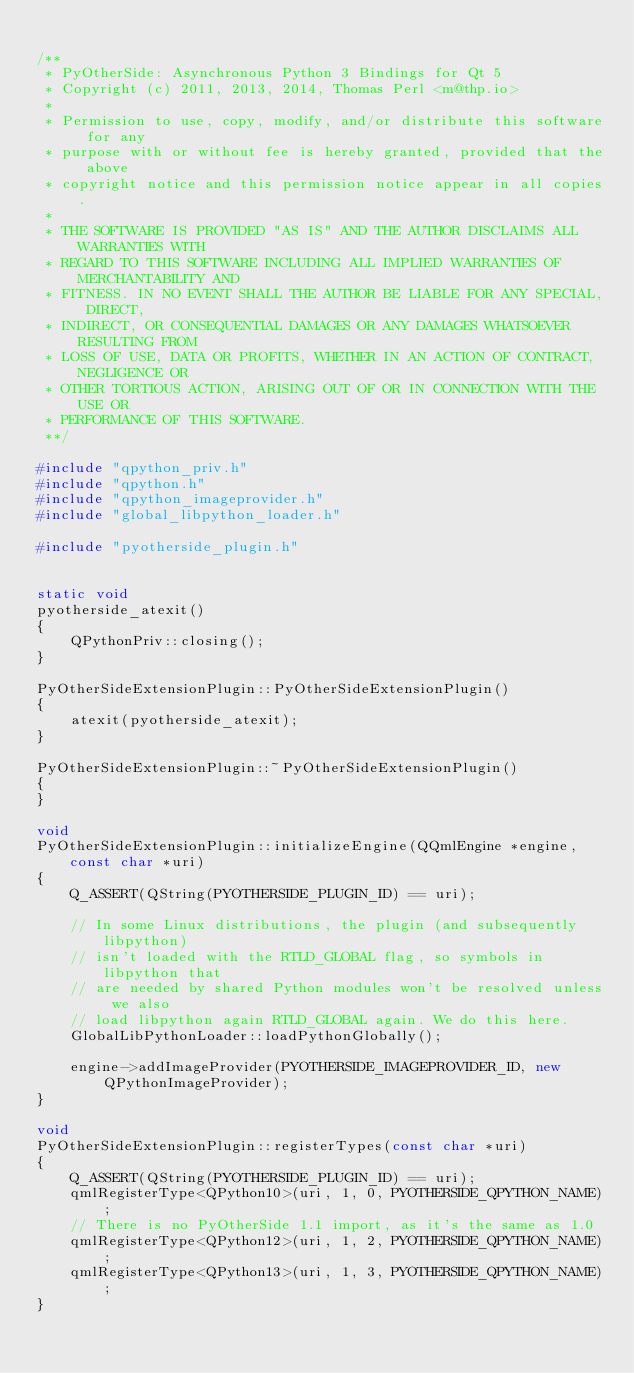Convert code to text. <code><loc_0><loc_0><loc_500><loc_500><_C++_>
/**
 * PyOtherSide: Asynchronous Python 3 Bindings for Qt 5
 * Copyright (c) 2011, 2013, 2014, Thomas Perl <m@thp.io>
 *
 * Permission to use, copy, modify, and/or distribute this software for any
 * purpose with or without fee is hereby granted, provided that the above
 * copyright notice and this permission notice appear in all copies.
 *
 * THE SOFTWARE IS PROVIDED "AS IS" AND THE AUTHOR DISCLAIMS ALL WARRANTIES WITH
 * REGARD TO THIS SOFTWARE INCLUDING ALL IMPLIED WARRANTIES OF MERCHANTABILITY AND
 * FITNESS. IN NO EVENT SHALL THE AUTHOR BE LIABLE FOR ANY SPECIAL, DIRECT,
 * INDIRECT, OR CONSEQUENTIAL DAMAGES OR ANY DAMAGES WHATSOEVER RESULTING FROM
 * LOSS OF USE, DATA OR PROFITS, WHETHER IN AN ACTION OF CONTRACT, NEGLIGENCE OR
 * OTHER TORTIOUS ACTION, ARISING OUT OF OR IN CONNECTION WITH THE USE OR
 * PERFORMANCE OF THIS SOFTWARE.
 **/

#include "qpython_priv.h"
#include "qpython.h"
#include "qpython_imageprovider.h"
#include "global_libpython_loader.h"

#include "pyotherside_plugin.h"


static void
pyotherside_atexit()
{
    QPythonPriv::closing();
}

PyOtherSideExtensionPlugin::PyOtherSideExtensionPlugin()
{
    atexit(pyotherside_atexit);
}

PyOtherSideExtensionPlugin::~PyOtherSideExtensionPlugin()
{
}

void
PyOtherSideExtensionPlugin::initializeEngine(QQmlEngine *engine, const char *uri)
{
    Q_ASSERT(QString(PYOTHERSIDE_PLUGIN_ID) == uri);

    // In some Linux distributions, the plugin (and subsequently libpython)
    // isn't loaded with the RTLD_GLOBAL flag, so symbols in libpython that
    // are needed by shared Python modules won't be resolved unless we also
    // load libpython again RTLD_GLOBAL again. We do this here.
    GlobalLibPythonLoader::loadPythonGlobally();

    engine->addImageProvider(PYOTHERSIDE_IMAGEPROVIDER_ID, new QPythonImageProvider);
}

void
PyOtherSideExtensionPlugin::registerTypes(const char *uri)
{
    Q_ASSERT(QString(PYOTHERSIDE_PLUGIN_ID) == uri);
    qmlRegisterType<QPython10>(uri, 1, 0, PYOTHERSIDE_QPYTHON_NAME);
    // There is no PyOtherSide 1.1 import, as it's the same as 1.0
    qmlRegisterType<QPython12>(uri, 1, 2, PYOTHERSIDE_QPYTHON_NAME);
    qmlRegisterType<QPython13>(uri, 1, 3, PYOTHERSIDE_QPYTHON_NAME);
}
</code> 